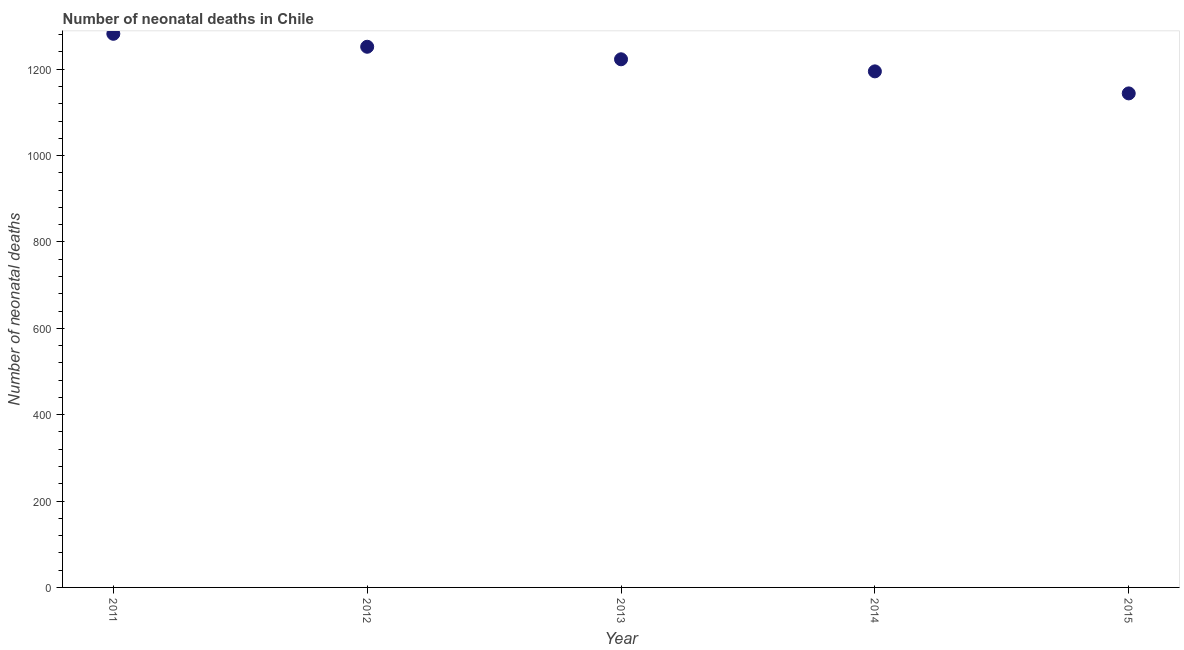What is the number of neonatal deaths in 2011?
Provide a succinct answer. 1282. Across all years, what is the maximum number of neonatal deaths?
Your answer should be very brief. 1282. Across all years, what is the minimum number of neonatal deaths?
Give a very brief answer. 1144. In which year was the number of neonatal deaths minimum?
Provide a succinct answer. 2015. What is the sum of the number of neonatal deaths?
Provide a short and direct response. 6096. What is the difference between the number of neonatal deaths in 2011 and 2015?
Provide a succinct answer. 138. What is the average number of neonatal deaths per year?
Ensure brevity in your answer.  1219.2. What is the median number of neonatal deaths?
Your response must be concise. 1223. In how many years, is the number of neonatal deaths greater than 320 ?
Keep it short and to the point. 5. Do a majority of the years between 2015 and 2011 (inclusive) have number of neonatal deaths greater than 560 ?
Your answer should be compact. Yes. What is the ratio of the number of neonatal deaths in 2012 to that in 2013?
Offer a terse response. 1.02. What is the difference between the highest and the lowest number of neonatal deaths?
Give a very brief answer. 138. Are the values on the major ticks of Y-axis written in scientific E-notation?
Your answer should be compact. No. Does the graph contain grids?
Offer a terse response. No. What is the title of the graph?
Your response must be concise. Number of neonatal deaths in Chile. What is the label or title of the X-axis?
Provide a short and direct response. Year. What is the label or title of the Y-axis?
Keep it short and to the point. Number of neonatal deaths. What is the Number of neonatal deaths in 2011?
Offer a terse response. 1282. What is the Number of neonatal deaths in 2012?
Your answer should be compact. 1252. What is the Number of neonatal deaths in 2013?
Provide a short and direct response. 1223. What is the Number of neonatal deaths in 2014?
Keep it short and to the point. 1195. What is the Number of neonatal deaths in 2015?
Offer a terse response. 1144. What is the difference between the Number of neonatal deaths in 2011 and 2014?
Give a very brief answer. 87. What is the difference between the Number of neonatal deaths in 2011 and 2015?
Keep it short and to the point. 138. What is the difference between the Number of neonatal deaths in 2012 and 2013?
Make the answer very short. 29. What is the difference between the Number of neonatal deaths in 2012 and 2015?
Make the answer very short. 108. What is the difference between the Number of neonatal deaths in 2013 and 2015?
Your answer should be very brief. 79. What is the ratio of the Number of neonatal deaths in 2011 to that in 2013?
Offer a terse response. 1.05. What is the ratio of the Number of neonatal deaths in 2011 to that in 2014?
Your answer should be compact. 1.07. What is the ratio of the Number of neonatal deaths in 2011 to that in 2015?
Keep it short and to the point. 1.12. What is the ratio of the Number of neonatal deaths in 2012 to that in 2014?
Keep it short and to the point. 1.05. What is the ratio of the Number of neonatal deaths in 2012 to that in 2015?
Your response must be concise. 1.09. What is the ratio of the Number of neonatal deaths in 2013 to that in 2015?
Your response must be concise. 1.07. What is the ratio of the Number of neonatal deaths in 2014 to that in 2015?
Your answer should be compact. 1.04. 